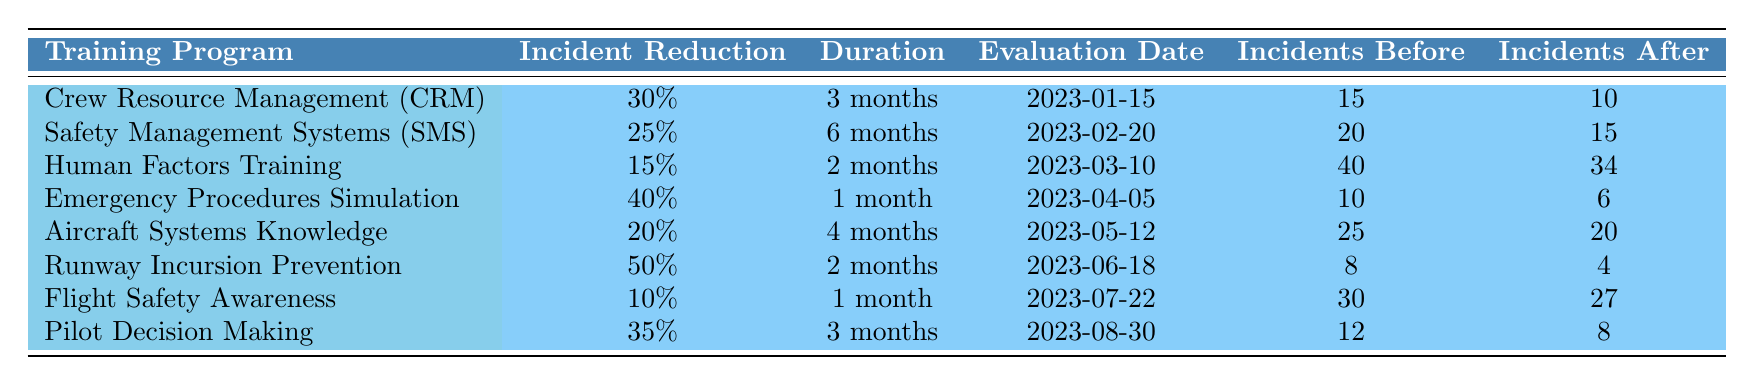What is the incident reduction for the Emergency Procedures Simulation training program? The data for the Emergency Procedures Simulation training program shows an Incident Reduction value of 40%. This value is directly taken from the corresponding row in the table.
Answer: 40% Which training program had the longest duration? The Safety Management Systems training program has the longest duration, lasting 6 months, which is the highest duration listed in the table.
Answer: Safety Management Systems (SMS) What is the average incident count before training across all programs? To find the average incident count before training, we sum the incidents before training: (15 + 20 + 40 + 10 + 25 + 8 + 30 + 12) = 160. We then divide by the number of programs (8) to get the average: 160 / 8 = 20.
Answer: 20 Did the Flight Safety Awareness program achieve a reduction in incidents? Yes, the Flight Safety Awareness program had an Incident Count Before of 30 and an Incident Count After of 27, indicating a reduction in incidents.
Answer: Yes What is the total reduction in incidents for training programs with over 30% incident reduction? The training programs with over 30% incident reduction are Crew Resource Management (30%), Emergency Procedures Simulation (40%), and Pilot Decision Making (35%). Summing the incident reductions: 30% + 40% + 35% = 105%. This total indicates the combined reduction rate of these three programs.
Answer: 105% 